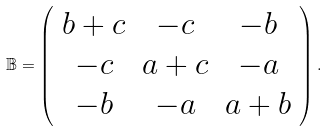Convert formula to latex. <formula><loc_0><loc_0><loc_500><loc_500>\mathbb { B } = \left ( \begin{array} { c c c } b + c & - c & - b \\ - c & a + c & - a \\ - b & - a & a + b \end{array} \right ) .</formula> 